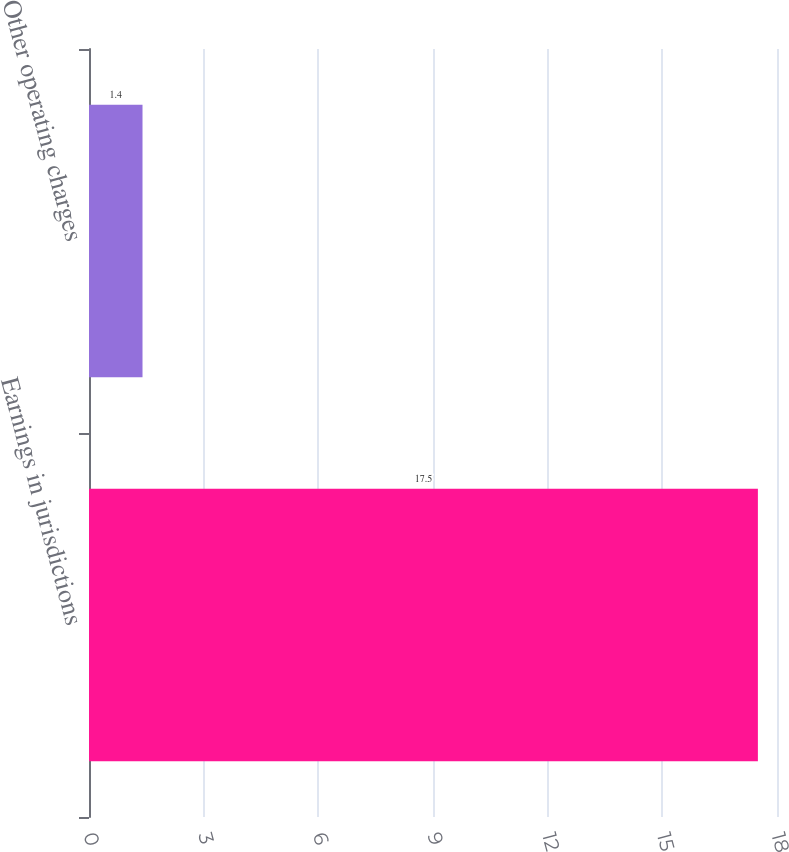Convert chart to OTSL. <chart><loc_0><loc_0><loc_500><loc_500><bar_chart><fcel>Earnings in jurisdictions<fcel>Other operating charges<nl><fcel>17.5<fcel>1.4<nl></chart> 